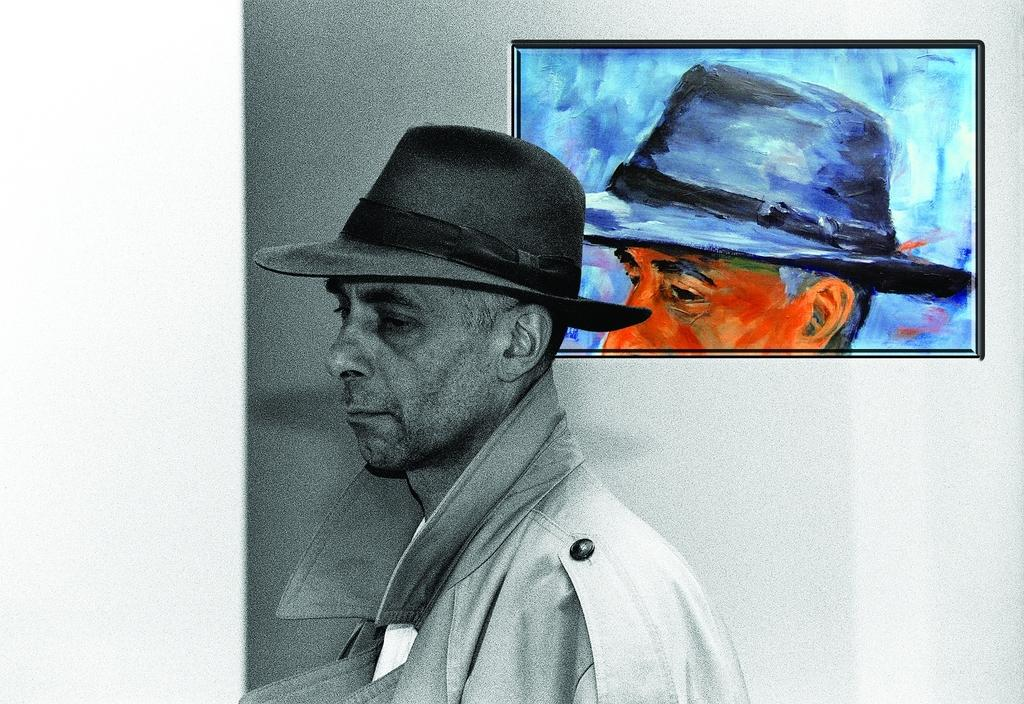Who is present in the image? There is a person in the image. What is the person wearing on their head? The person is wearing a cap. What can be seen in the background of the image? There is a wall in the image. Is there any decoration or object attached to the wall? Yes, there is a photo frame attached to the wall. What is the person's tendency to order suits in the image? There is no information about the person's tendency to order suits in the image. 